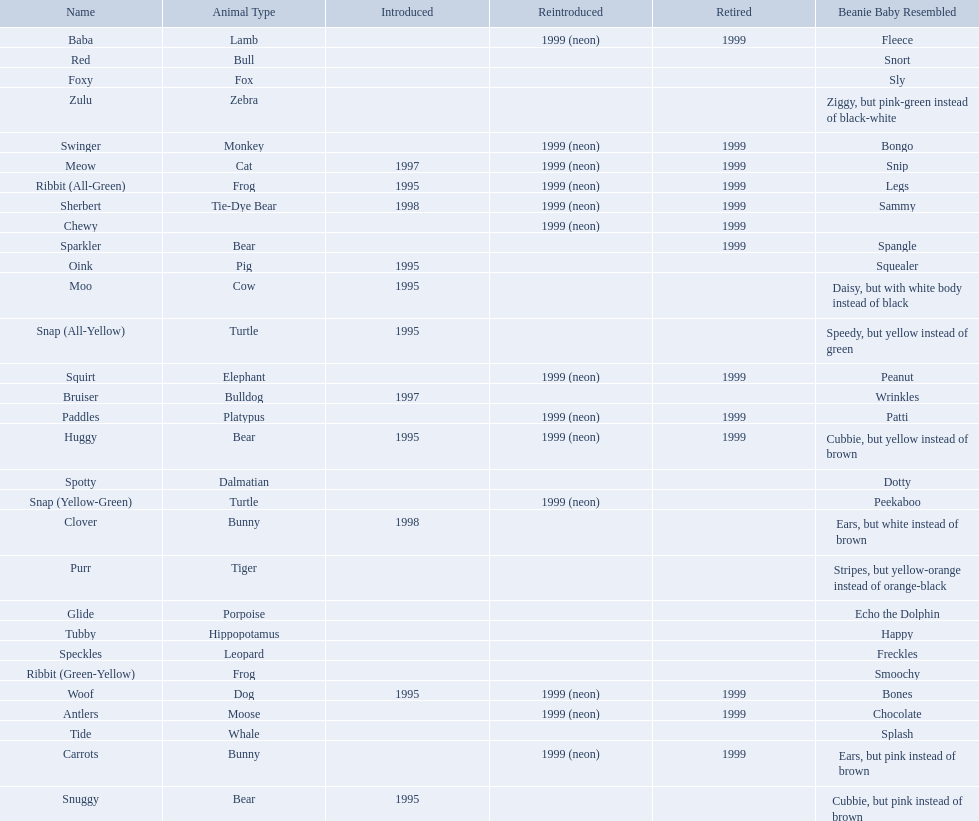Which of the listed pillow pals lack information in at least 3 categories? Chewy, Foxy, Glide, Purr, Red, Ribbit (Green-Yellow), Speckles, Spotty, Tide, Tubby, Zulu. Would you mind parsing the complete table? {'header': ['Name', 'Animal Type', 'Introduced', 'Reintroduced', 'Retired', 'Beanie Baby Resembled'], 'rows': [['Baba', 'Lamb', '', '1999 (neon)', '1999', 'Fleece'], ['Red', 'Bull', '', '', '', 'Snort'], ['Foxy', 'Fox', '', '', '', 'Sly'], ['Zulu', 'Zebra', '', '', '', 'Ziggy, but pink-green instead of black-white'], ['Swinger', 'Monkey', '', '1999 (neon)', '1999', 'Bongo'], ['Meow', 'Cat', '1997', '1999 (neon)', '1999', 'Snip'], ['Ribbit (All-Green)', 'Frog', '1995', '1999 (neon)', '1999', 'Legs'], ['Sherbert', 'Tie-Dye Bear', '1998', '1999 (neon)', '1999', 'Sammy'], ['Chewy', '', '', '1999 (neon)', '1999', ''], ['Sparkler', 'Bear', '', '', '1999', 'Spangle'], ['Oink', 'Pig', '1995', '', '', 'Squealer'], ['Moo', 'Cow', '1995', '', '', 'Daisy, but with white body instead of black'], ['Snap (All-Yellow)', 'Turtle', '1995', '', '', 'Speedy, but yellow instead of green'], ['Squirt', 'Elephant', '', '1999 (neon)', '1999', 'Peanut'], ['Bruiser', 'Bulldog', '1997', '', '', 'Wrinkles'], ['Paddles', 'Platypus', '', '1999 (neon)', '1999', 'Patti'], ['Huggy', 'Bear', '1995', '1999 (neon)', '1999', 'Cubbie, but yellow instead of brown'], ['Spotty', 'Dalmatian', '', '', '', 'Dotty'], ['Snap (Yellow-Green)', 'Turtle', '', '1999 (neon)', '', 'Peekaboo'], ['Clover', 'Bunny', '1998', '', '', 'Ears, but white instead of brown'], ['Purr', 'Tiger', '', '', '', 'Stripes, but yellow-orange instead of orange-black'], ['Glide', 'Porpoise', '', '', '', 'Echo the Dolphin'], ['Tubby', 'Hippopotamus', '', '', '', 'Happy'], ['Speckles', 'Leopard', '', '', '', 'Freckles'], ['Ribbit (Green-Yellow)', 'Frog', '', '', '', 'Smoochy'], ['Woof', 'Dog', '1995', '1999 (neon)', '1999', 'Bones'], ['Antlers', 'Moose', '', '1999 (neon)', '1999', 'Chocolate'], ['Tide', 'Whale', '', '', '', 'Splash'], ['Carrots', 'Bunny', '', '1999 (neon)', '1999', 'Ears, but pink instead of brown'], ['Snuggy', 'Bear', '1995', '', '', 'Cubbie, but pink instead of brown']]} Of those, which one lacks information in the animal type category? Chewy. 